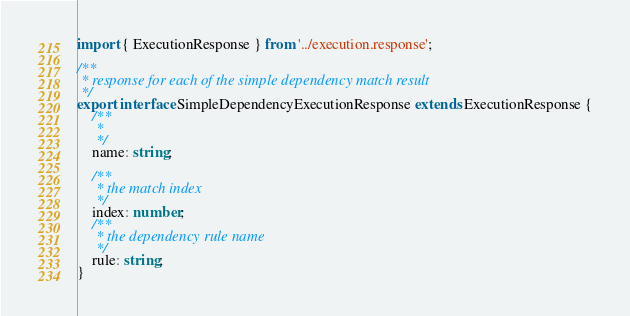<code> <loc_0><loc_0><loc_500><loc_500><_TypeScript_>import { ExecutionResponse } from '../execution.response';

/**
 * response for each of the simple dependency match result
 */
export interface SimpleDependencyExecutionResponse extends ExecutionResponse {
    /**
     *
     */
    name: string;

    /**
     * the match index
     */
    index: number;
    /**
     * the dependency rule name
     */
    rule: string;
}
</code> 